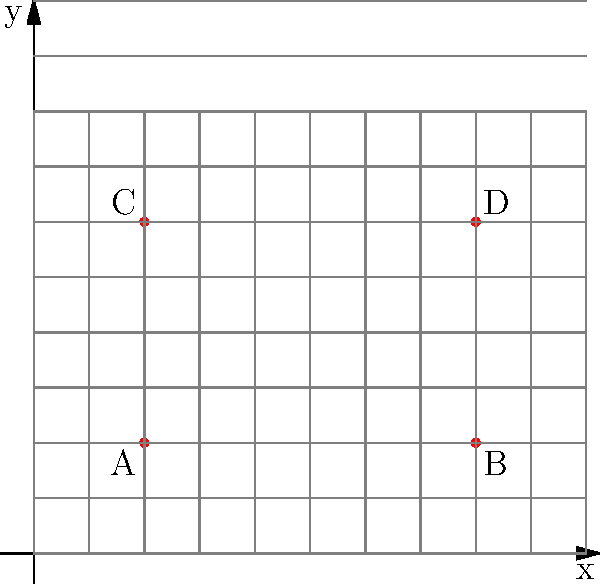In your restaurant floor plan, you've installed four air quality sensors at locations A(2,2), B(8,2), C(2,6), and D(8,6). What is the total distance between sensors A and C, and sensors B and D combined? To solve this problem, we need to calculate the distances between sensors A and C, and between sensors B and D, then add them together. We can use the distance formula in a 2D coordinate system:

$d = \sqrt{(x_2-x_1)^2 + (y_2-y_1)^2}$

1. Distance between A(2,2) and C(2,6):
   $d_{AC} = \sqrt{(2-2)^2 + (6-2)^2} = \sqrt{0^2 + 4^2} = \sqrt{16} = 4$

2. Distance between B(8,2) and D(8,6):
   $d_{BD} = \sqrt{(8-8)^2 + (6-2)^2} = \sqrt{0^2 + 4^2} = \sqrt{16} = 4$

3. Total distance:
   $d_{total} = d_{AC} + d_{BD} = 4 + 4 = 8$

Therefore, the total distance between sensors A and C, and sensors B and D combined is 8 units.
Answer: 8 units 